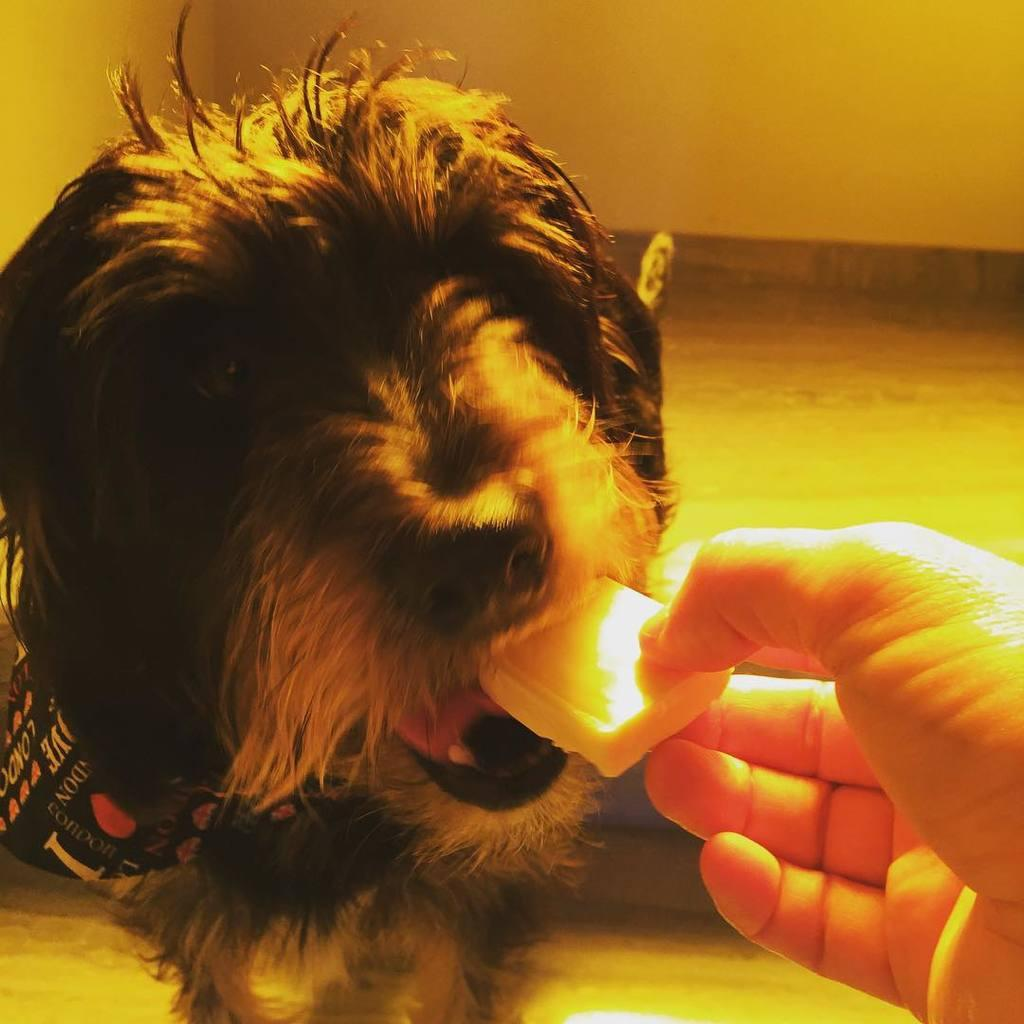What animal is sitting on the floor in the image? There is a dog sitting on the floor in the image. What can be seen on the right side of the image? A person's hand is visible on the right side of the image. What is the person holding? The person is holding food. What is the person doing with the food? The person is feeding the dog. What is visible in the background of the image? There is a wall in the background of the image. What type of lipstick is the dog wearing in the image? There is no lipstick or any indication of makeup on the dog in the image. How does the beginner dog trainer handle the dog in the image? There is no mention of a dog trainer or any training in the image; the person is simply feeding the dog. 